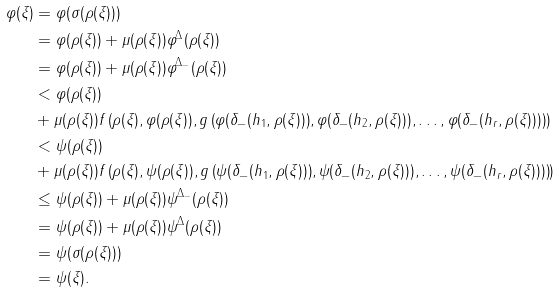Convert formula to latex. <formula><loc_0><loc_0><loc_500><loc_500>\varphi ( \xi ) & = \varphi ( \sigma ( \rho ( \xi ) ) ) \\ & = \varphi ( \rho ( \xi ) ) + \mu ( \rho ( \xi ) ) \varphi ^ { \Delta } ( \rho ( \xi ) ) \\ & = \varphi ( \rho ( \xi ) ) + \mu ( \rho ( \xi ) ) \varphi ^ { \Delta _ { - } } ( \rho ( \xi ) ) \\ & < \varphi ( \rho ( \xi ) ) \\ & + \mu ( \rho ( \xi ) ) f \left ( \rho ( \xi ) , \varphi ( \rho ( \xi ) ) , g \left ( \varphi ( \delta _ { - } ( h _ { 1 } , \rho ( \xi ) ) ) , \varphi ( \delta _ { - } ( h _ { 2 } , \rho ( \xi ) ) ) , \dots , \varphi ( \delta _ { - } ( h _ { r } , \rho ( \xi ) ) ) \right ) \right ) \\ & < \psi ( \rho ( \xi ) ) \\ & + \mu ( \rho ( \xi ) ) f \left ( \rho ( \xi ) , \psi ( \rho ( \xi ) ) , g \left ( \psi ( \delta _ { - } ( h _ { 1 } , \rho ( \xi ) ) ) , \psi ( \delta _ { - } ( h _ { 2 } , \rho ( \xi ) ) ) , \dots , \psi ( \delta _ { - } ( h _ { r } , \rho ( \xi ) ) ) \right ) \right ) \\ & \leq \psi ( \rho ( \xi ) ) + \mu ( \rho ( \xi ) ) \psi ^ { \Delta _ { - } } ( \rho ( \xi ) ) \\ & = \psi ( \rho ( \xi ) ) + \mu ( \rho ( \xi ) ) \psi ^ { \Delta } ( \rho ( \xi ) ) \\ & = \psi ( \sigma ( \rho ( \xi ) ) ) \\ & = \psi ( \xi ) .</formula> 